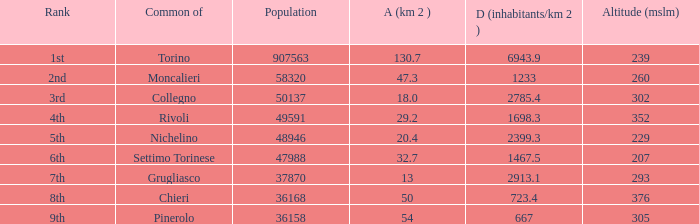How many altitudes does the common with an area of 130.7 km^2 have? 1.0. 